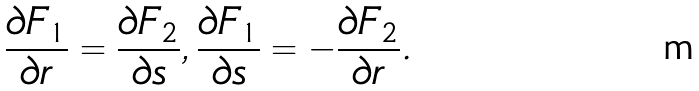Convert formula to latex. <formula><loc_0><loc_0><loc_500><loc_500>\frac { \partial F _ { 1 } } { \partial r } = \frac { \partial F _ { 2 } } { \partial s } , \frac { \partial F _ { 1 } } { \partial s } = - \frac { \partial F _ { 2 } } { \partial r } .</formula> 